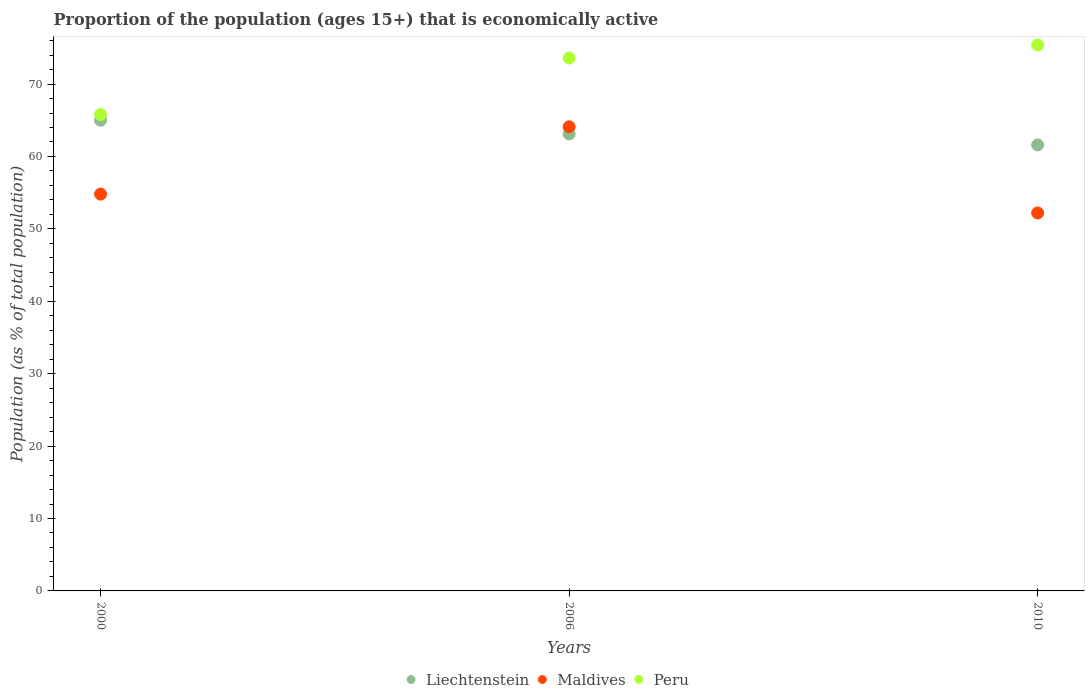Is the number of dotlines equal to the number of legend labels?
Offer a terse response. Yes. What is the proportion of the population that is economically active in Liechtenstein in 2000?
Your answer should be very brief. 65. Across all years, what is the maximum proportion of the population that is economically active in Maldives?
Provide a succinct answer. 64.1. Across all years, what is the minimum proportion of the population that is economically active in Peru?
Give a very brief answer. 65.8. What is the total proportion of the population that is economically active in Peru in the graph?
Ensure brevity in your answer.  214.8. What is the difference between the proportion of the population that is economically active in Maldives in 2000 and that in 2010?
Make the answer very short. 2.6. What is the difference between the proportion of the population that is economically active in Liechtenstein in 2000 and the proportion of the population that is economically active in Peru in 2010?
Make the answer very short. -10.4. What is the average proportion of the population that is economically active in Maldives per year?
Your answer should be compact. 57.03. In the year 2000, what is the difference between the proportion of the population that is economically active in Peru and proportion of the population that is economically active in Maldives?
Offer a very short reply. 11. In how many years, is the proportion of the population that is economically active in Peru greater than 30 %?
Provide a succinct answer. 3. What is the ratio of the proportion of the population that is economically active in Peru in 2000 to that in 2010?
Offer a terse response. 0.87. Is the proportion of the population that is economically active in Peru in 2006 less than that in 2010?
Provide a succinct answer. Yes. What is the difference between the highest and the second highest proportion of the population that is economically active in Peru?
Ensure brevity in your answer.  1.8. What is the difference between the highest and the lowest proportion of the population that is economically active in Liechtenstein?
Your answer should be very brief. 3.4. In how many years, is the proportion of the population that is economically active in Liechtenstein greater than the average proportion of the population that is economically active in Liechtenstein taken over all years?
Your answer should be compact. 1. Does the proportion of the population that is economically active in Liechtenstein monotonically increase over the years?
Offer a terse response. No. Is the proportion of the population that is economically active in Maldives strictly less than the proportion of the population that is economically active in Liechtenstein over the years?
Give a very brief answer. No. How many dotlines are there?
Your answer should be compact. 3. Are the values on the major ticks of Y-axis written in scientific E-notation?
Your answer should be compact. No. Does the graph contain any zero values?
Offer a very short reply. No. Does the graph contain grids?
Provide a short and direct response. No. Where does the legend appear in the graph?
Your answer should be very brief. Bottom center. How are the legend labels stacked?
Your response must be concise. Horizontal. What is the title of the graph?
Give a very brief answer. Proportion of the population (ages 15+) that is economically active. Does "Ireland" appear as one of the legend labels in the graph?
Provide a short and direct response. No. What is the label or title of the X-axis?
Your answer should be very brief. Years. What is the label or title of the Y-axis?
Provide a short and direct response. Population (as % of total population). What is the Population (as % of total population) of Maldives in 2000?
Ensure brevity in your answer.  54.8. What is the Population (as % of total population) in Peru in 2000?
Give a very brief answer. 65.8. What is the Population (as % of total population) of Liechtenstein in 2006?
Make the answer very short. 63.1. What is the Population (as % of total population) in Maldives in 2006?
Offer a very short reply. 64.1. What is the Population (as % of total population) of Peru in 2006?
Ensure brevity in your answer.  73.6. What is the Population (as % of total population) in Liechtenstein in 2010?
Provide a short and direct response. 61.6. What is the Population (as % of total population) in Maldives in 2010?
Provide a short and direct response. 52.2. What is the Population (as % of total population) in Peru in 2010?
Offer a terse response. 75.4. Across all years, what is the maximum Population (as % of total population) in Liechtenstein?
Ensure brevity in your answer.  65. Across all years, what is the maximum Population (as % of total population) in Maldives?
Provide a short and direct response. 64.1. Across all years, what is the maximum Population (as % of total population) of Peru?
Your answer should be compact. 75.4. Across all years, what is the minimum Population (as % of total population) of Liechtenstein?
Ensure brevity in your answer.  61.6. Across all years, what is the minimum Population (as % of total population) of Maldives?
Provide a short and direct response. 52.2. Across all years, what is the minimum Population (as % of total population) in Peru?
Your response must be concise. 65.8. What is the total Population (as % of total population) in Liechtenstein in the graph?
Give a very brief answer. 189.7. What is the total Population (as % of total population) of Maldives in the graph?
Provide a succinct answer. 171.1. What is the total Population (as % of total population) in Peru in the graph?
Your answer should be compact. 214.8. What is the difference between the Population (as % of total population) of Liechtenstein in 2000 and that in 2006?
Keep it short and to the point. 1.9. What is the difference between the Population (as % of total population) of Liechtenstein in 2006 and that in 2010?
Offer a terse response. 1.5. What is the difference between the Population (as % of total population) in Maldives in 2000 and the Population (as % of total population) in Peru in 2006?
Keep it short and to the point. -18.8. What is the difference between the Population (as % of total population) in Liechtenstein in 2000 and the Population (as % of total population) in Maldives in 2010?
Provide a short and direct response. 12.8. What is the difference between the Population (as % of total population) in Liechtenstein in 2000 and the Population (as % of total population) in Peru in 2010?
Keep it short and to the point. -10.4. What is the difference between the Population (as % of total population) of Maldives in 2000 and the Population (as % of total population) of Peru in 2010?
Provide a succinct answer. -20.6. What is the difference between the Population (as % of total population) of Liechtenstein in 2006 and the Population (as % of total population) of Maldives in 2010?
Make the answer very short. 10.9. What is the average Population (as % of total population) in Liechtenstein per year?
Your response must be concise. 63.23. What is the average Population (as % of total population) of Maldives per year?
Your answer should be very brief. 57.03. What is the average Population (as % of total population) in Peru per year?
Provide a succinct answer. 71.6. In the year 2000, what is the difference between the Population (as % of total population) in Liechtenstein and Population (as % of total population) in Maldives?
Provide a succinct answer. 10.2. In the year 2006, what is the difference between the Population (as % of total population) in Liechtenstein and Population (as % of total population) in Maldives?
Your response must be concise. -1. In the year 2010, what is the difference between the Population (as % of total population) of Maldives and Population (as % of total population) of Peru?
Offer a very short reply. -23.2. What is the ratio of the Population (as % of total population) in Liechtenstein in 2000 to that in 2006?
Provide a succinct answer. 1.03. What is the ratio of the Population (as % of total population) of Maldives in 2000 to that in 2006?
Give a very brief answer. 0.85. What is the ratio of the Population (as % of total population) in Peru in 2000 to that in 2006?
Keep it short and to the point. 0.89. What is the ratio of the Population (as % of total population) of Liechtenstein in 2000 to that in 2010?
Make the answer very short. 1.06. What is the ratio of the Population (as % of total population) of Maldives in 2000 to that in 2010?
Ensure brevity in your answer.  1.05. What is the ratio of the Population (as % of total population) of Peru in 2000 to that in 2010?
Your answer should be very brief. 0.87. What is the ratio of the Population (as % of total population) in Liechtenstein in 2006 to that in 2010?
Ensure brevity in your answer.  1.02. What is the ratio of the Population (as % of total population) in Maldives in 2006 to that in 2010?
Your response must be concise. 1.23. What is the ratio of the Population (as % of total population) of Peru in 2006 to that in 2010?
Offer a very short reply. 0.98. What is the difference between the highest and the lowest Population (as % of total population) of Liechtenstein?
Keep it short and to the point. 3.4. What is the difference between the highest and the lowest Population (as % of total population) in Maldives?
Your answer should be compact. 11.9. 